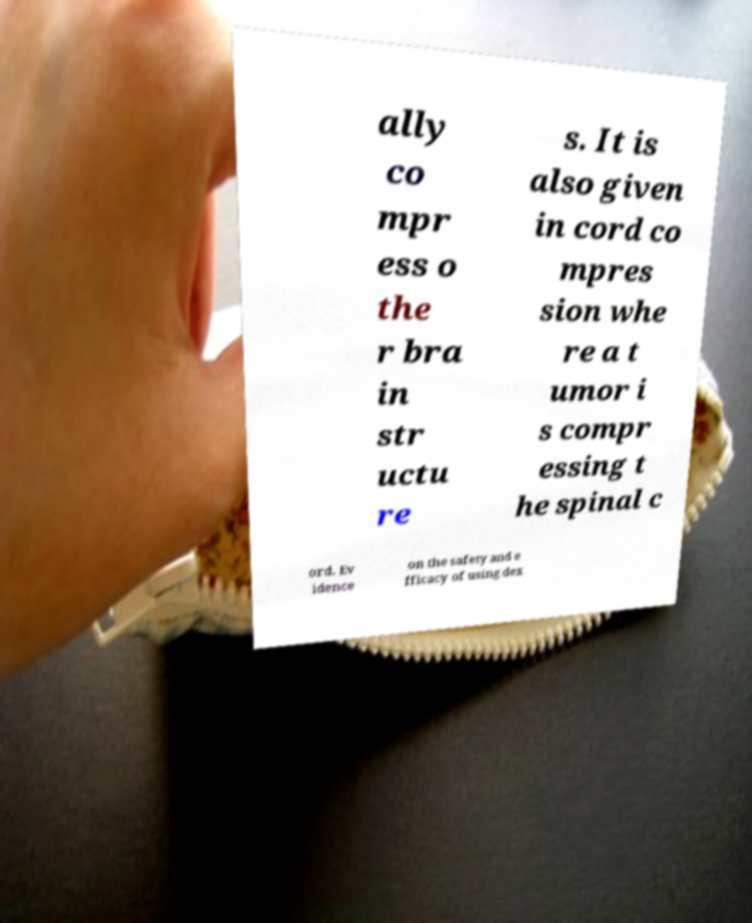Could you extract and type out the text from this image? ally co mpr ess o the r bra in str uctu re s. It is also given in cord co mpres sion whe re a t umor i s compr essing t he spinal c ord. Ev idence on the safety and e fficacy of using dex 